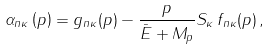<formula> <loc_0><loc_0><loc_500><loc_500>\alpha _ { n \kappa } \left ( p \right ) = g _ { n \kappa } ( p ) - \frac { p } { \bar { E } + M _ { p } } S _ { \kappa } \, f _ { n \kappa } ( p ) \, ,</formula> 